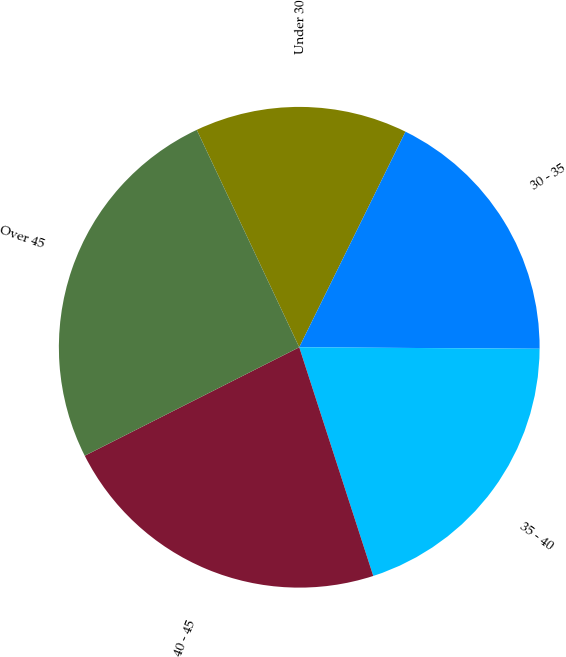Convert chart. <chart><loc_0><loc_0><loc_500><loc_500><pie_chart><fcel>Under 30<fcel>30 - 35<fcel>35 - 40<fcel>40 - 45<fcel>Over 45<nl><fcel>14.3%<fcel>17.81%<fcel>19.92%<fcel>22.53%<fcel>25.44%<nl></chart> 